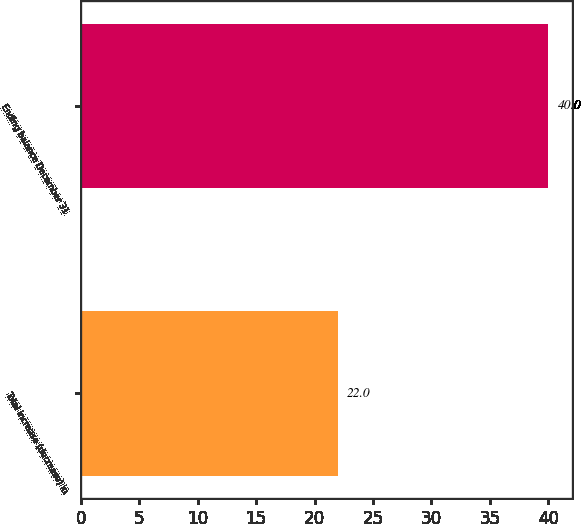Convert chart. <chart><loc_0><loc_0><loc_500><loc_500><bar_chart><fcel>Total increase (decrease) in<fcel>Ending balance December 31<nl><fcel>22<fcel>40<nl></chart> 